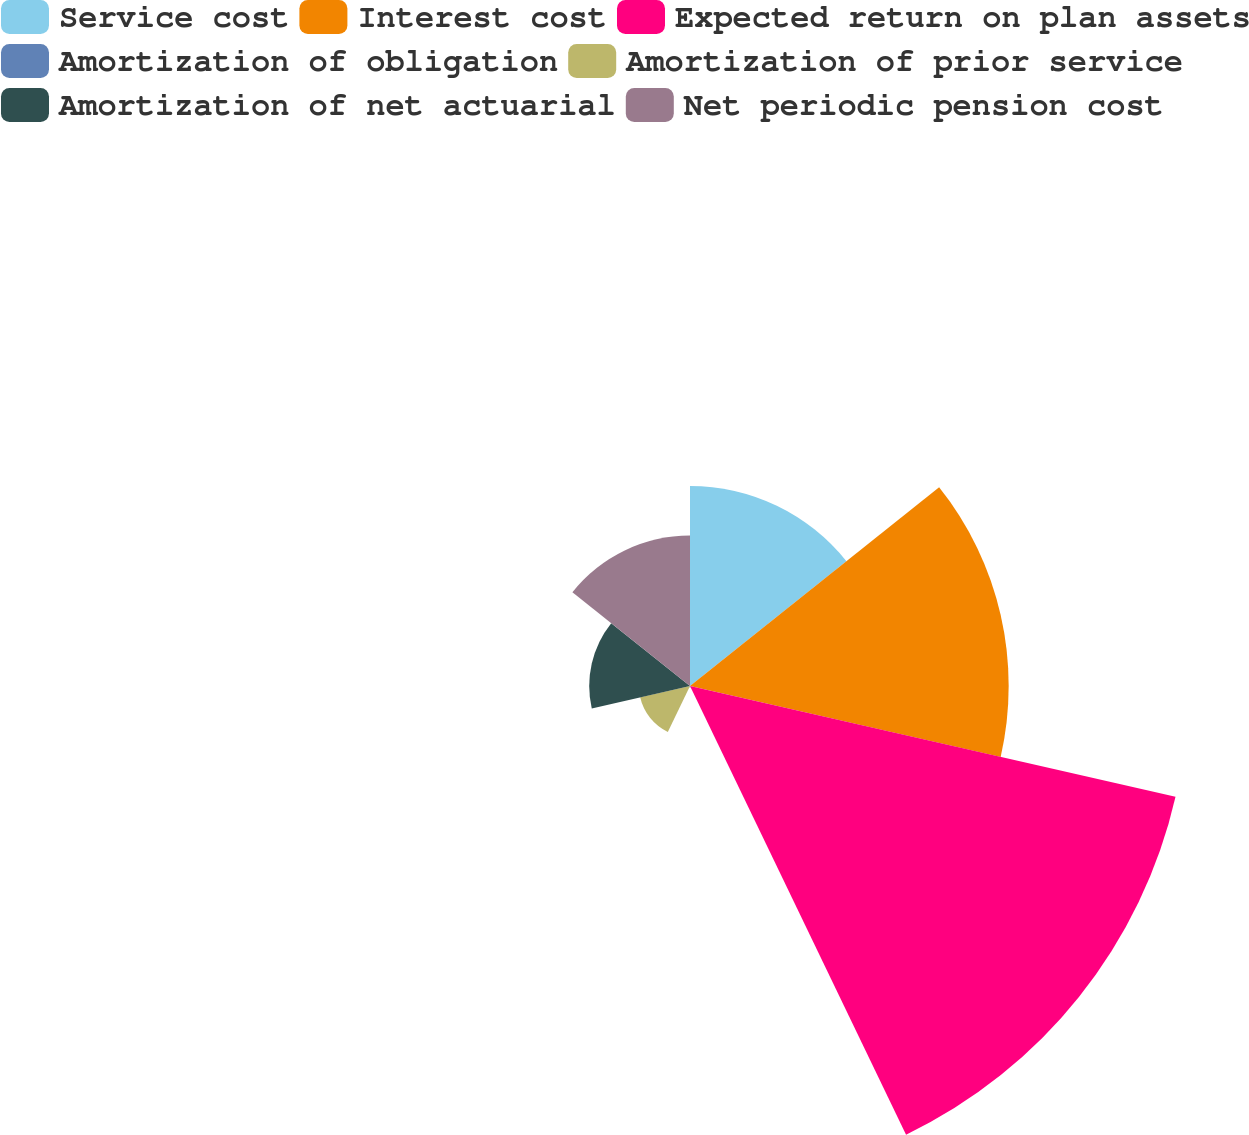Convert chart to OTSL. <chart><loc_0><loc_0><loc_500><loc_500><pie_chart><fcel>Service cost<fcel>Interest cost<fcel>Expected return on plan assets<fcel>Amortization of obligation<fcel>Amortization of prior service<fcel>Amortization of net actuarial<fcel>Net periodic pension cost<nl><fcel>15.15%<fcel>24.13%<fcel>37.71%<fcel>0.11%<fcel>3.87%<fcel>7.63%<fcel>11.39%<nl></chart> 